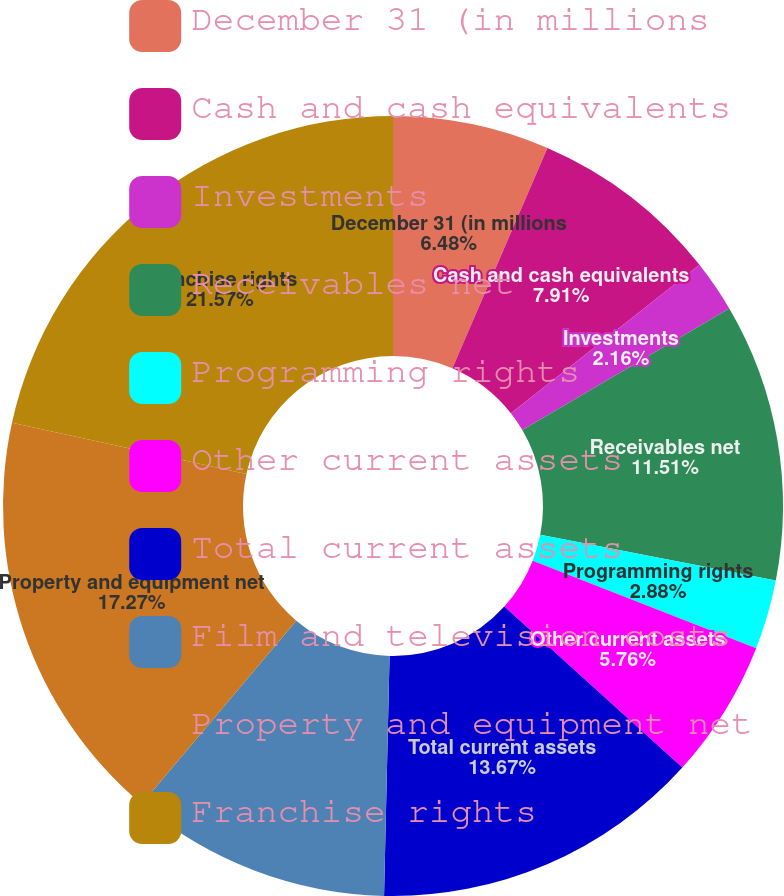<chart> <loc_0><loc_0><loc_500><loc_500><pie_chart><fcel>December 31 (in millions<fcel>Cash and cash equivalents<fcel>Investments<fcel>Receivables net<fcel>Programming rights<fcel>Other current assets<fcel>Total current assets<fcel>Film and television costs<fcel>Property and equipment net<fcel>Franchise rights<nl><fcel>6.48%<fcel>7.91%<fcel>2.16%<fcel>11.51%<fcel>2.88%<fcel>5.76%<fcel>13.67%<fcel>10.79%<fcel>17.27%<fcel>21.58%<nl></chart> 